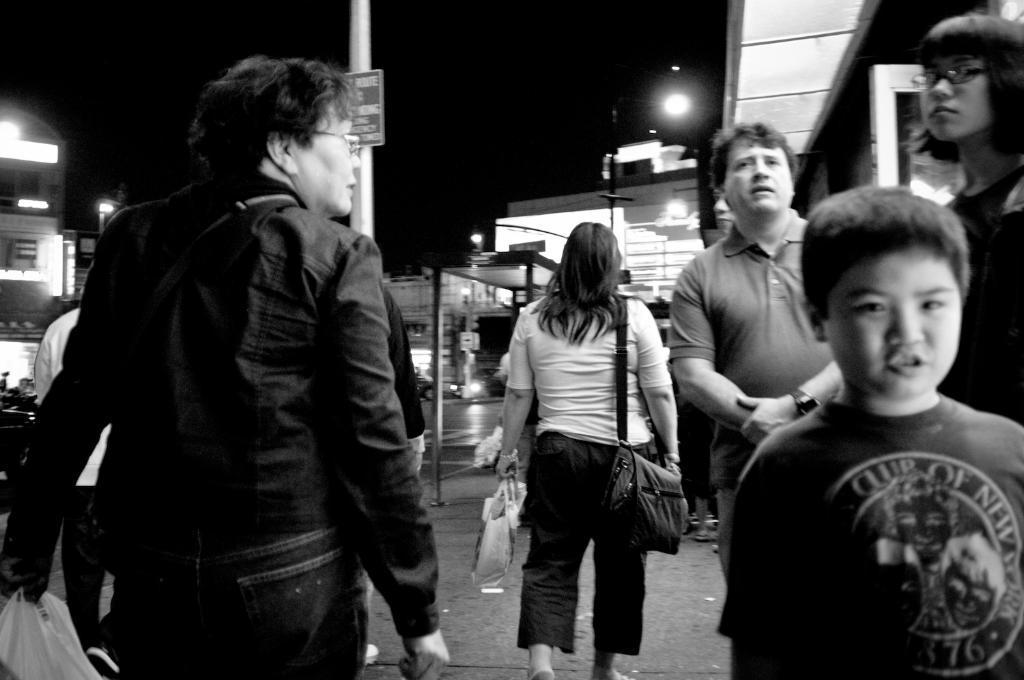Please provide a concise description of this image. In this image we can see persons standing on the street. In the background we can see buildings, street poles, street lights and sky. 